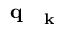Convert formula to latex. <formula><loc_0><loc_0><loc_500><loc_500>q _ { k }</formula> 